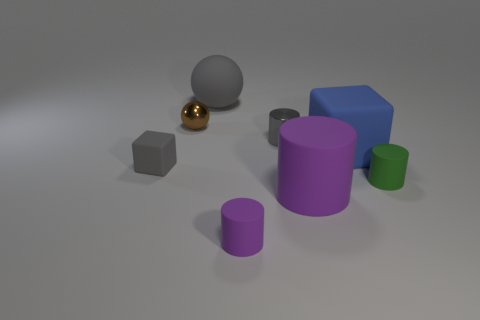What size is the matte cube on the right side of the big object that is left of the metallic cylinder?
Provide a succinct answer. Large. There is a small matte cylinder that is to the right of the tiny purple matte thing; what is its color?
Provide a short and direct response. Green. Is there a small gray shiny object that has the same shape as the small purple rubber thing?
Your answer should be very brief. Yes. Are there fewer big purple matte cylinders that are behind the rubber ball than blocks that are right of the brown metal ball?
Provide a succinct answer. Yes. The big ball has what color?
Your answer should be very brief. Gray. There is a purple matte object that is to the left of the gray metal thing; are there any matte cylinders that are to the right of it?
Offer a very short reply. Yes. How many brown spheres are the same size as the gray block?
Your answer should be very brief. 1. How many tiny gray things are on the right side of the small cylinder that is in front of the purple matte object that is to the right of the tiny gray cylinder?
Provide a succinct answer. 1. How many objects are right of the large purple matte object and in front of the tiny rubber block?
Make the answer very short. 1. Are there any other things that are the same color as the small matte cube?
Provide a short and direct response. Yes. 